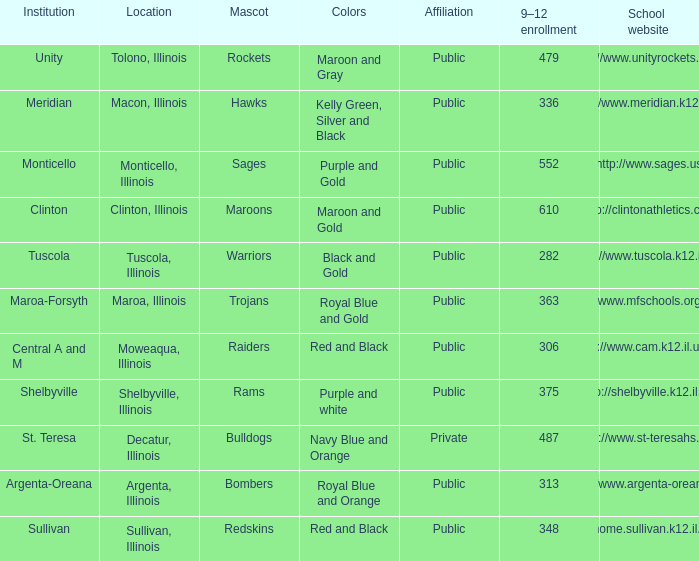How many different combinations of team colors are there in all the schools in Maroa, Illinois? 1.0. 